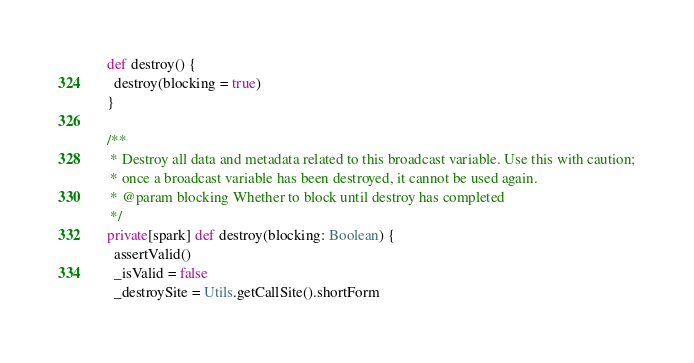<code> <loc_0><loc_0><loc_500><loc_500><_Scala_>  def destroy() {
    destroy(blocking = true)
  }

  /**
   * Destroy all data and metadata related to this broadcast variable. Use this with caution;
   * once a broadcast variable has been destroyed, it cannot be used again.
   * @param blocking Whether to block until destroy has completed
   */
  private[spark] def destroy(blocking: Boolean) {
    assertValid()
    _isValid = false
    _destroySite = Utils.getCallSite().shortForm</code> 